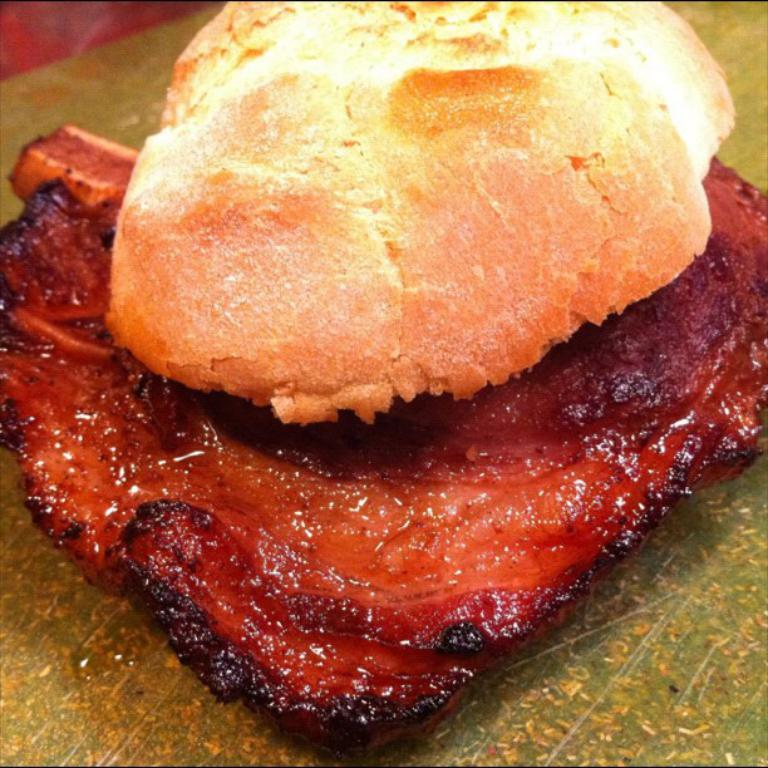What type of food is visible in the image? There is fried meat in the image. What is unique about the appearance of the fried meat? The fried meat has a puff on it. What is the fried meat placed on? The fried meat is on a plastic cover. Where is the plastic cover located? The plastic cover is on a table. What type of fiction is being read by the thumb in the image? There is no fiction or thumb present in the image; it features fried meat on a plastic cover on a table. 